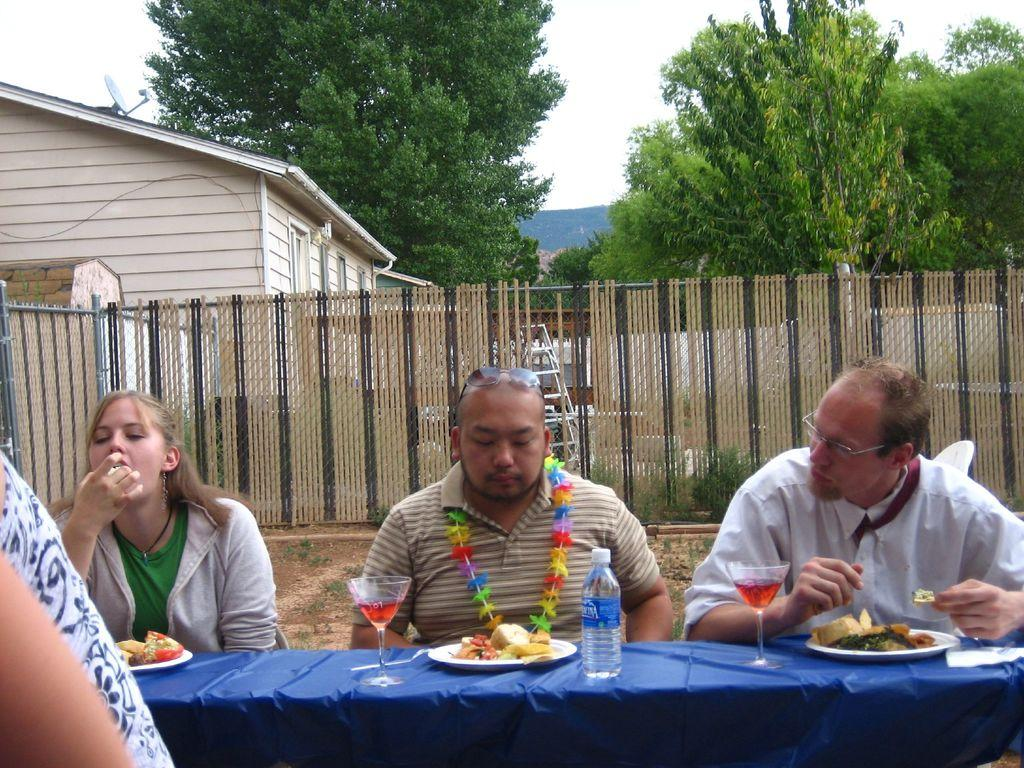How many people are sitting in the image? There are three people sitting on chairs in the image. What can be seen in the background of the image? There is a fence, a house, trees, and the sky visible in the image. What is on the table in the image? There is a blue color cloth, plates, a bottle, a glass, and dishes on the table in the image. What is there is any tendency of the yarn to unravel in the image? There is no yarn present in the image, so it is not possible to determine any tendencies related to yarn. What is the writing on the plates in the image? There is no writing visible on the plates in the image. 